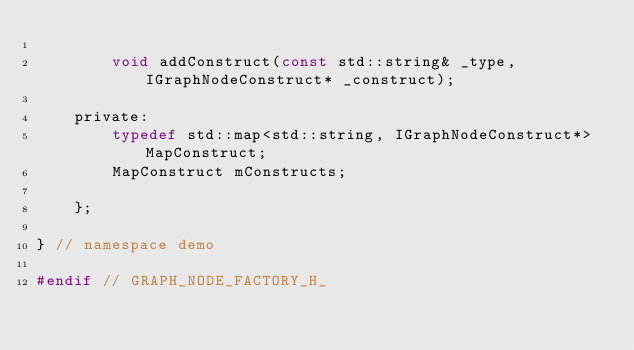Convert code to text. <code><loc_0><loc_0><loc_500><loc_500><_C_>
		void addConstruct(const std::string& _type, IGraphNodeConstruct* _construct);

	private:
		typedef std::map<std::string, IGraphNodeConstruct*> MapConstruct;
		MapConstruct mConstructs;

	};

} // namespace demo

#endif // GRAPH_NODE_FACTORY_H_
</code> 